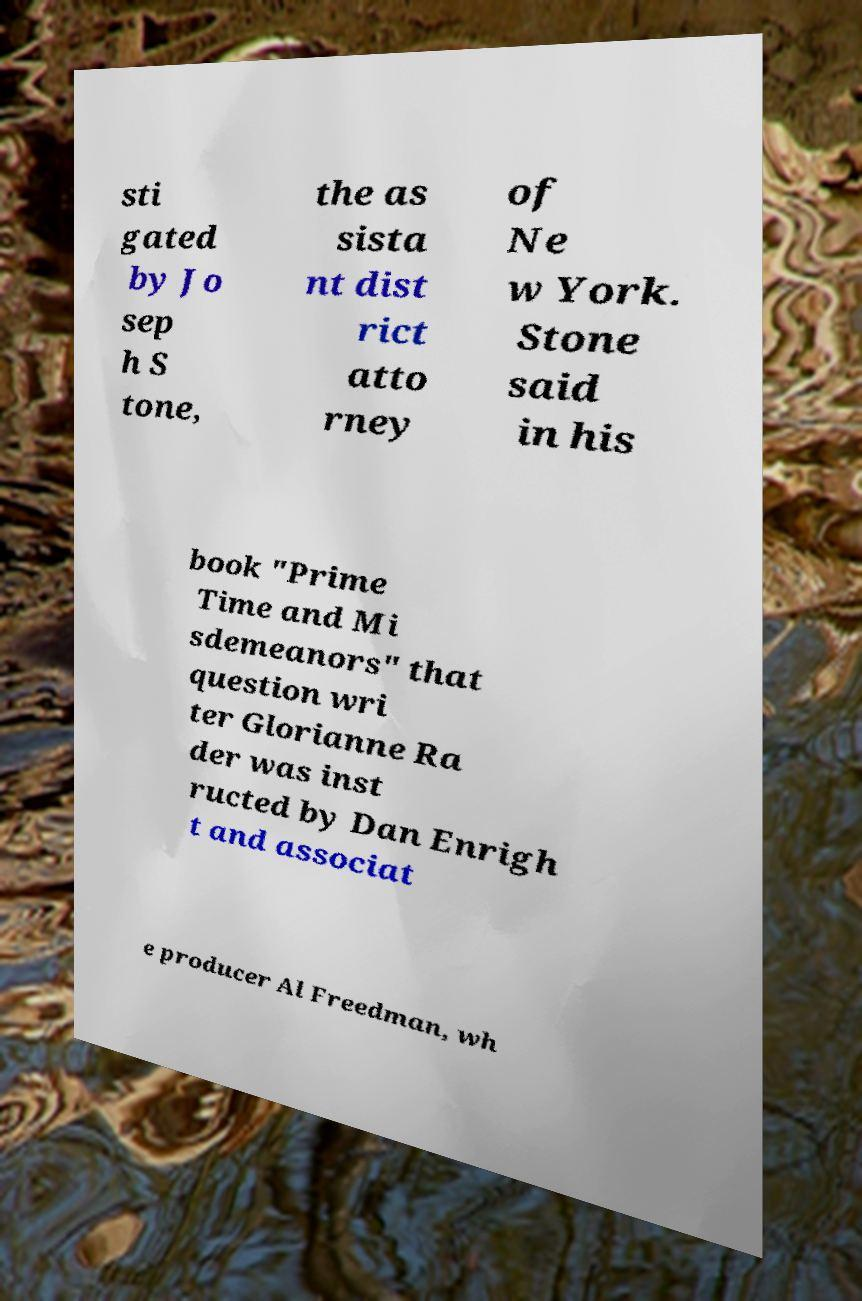I need the written content from this picture converted into text. Can you do that? sti gated by Jo sep h S tone, the as sista nt dist rict atto rney of Ne w York. Stone said in his book "Prime Time and Mi sdemeanors" that question wri ter Glorianne Ra der was inst ructed by Dan Enrigh t and associat e producer Al Freedman, wh 